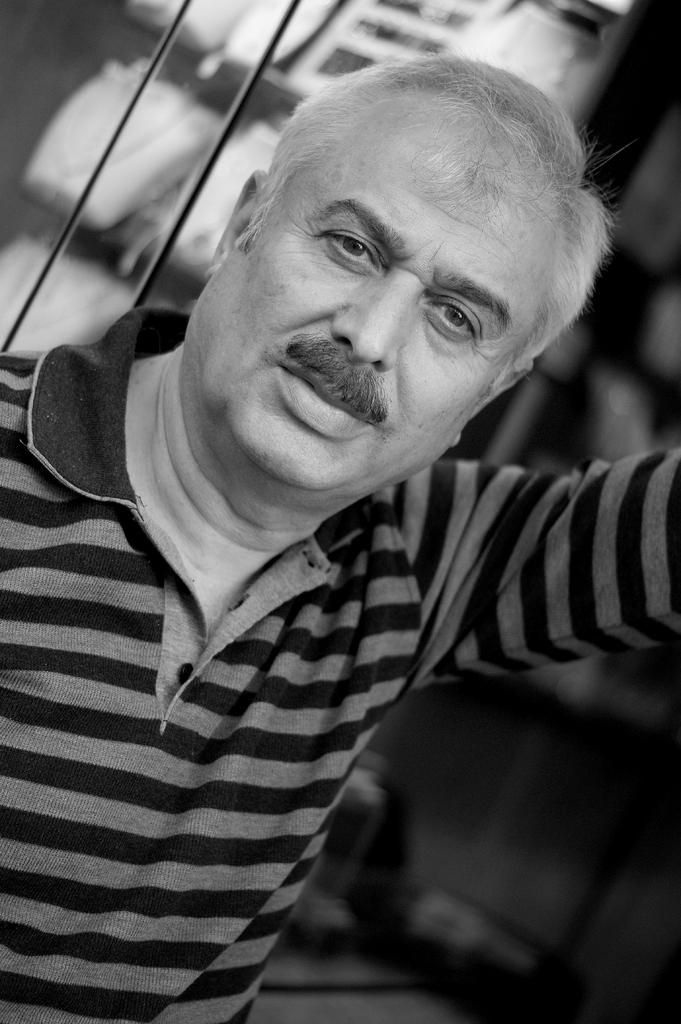What is the color scheme of the image? The image is black and white. Who or what is the main subject in the image? There is a man in the image. What can be seen behind the man in the image? The background contains glass and objects. How does the crowd affect the acoustics in the image? There is no crowd present in the image, so it is not possible to determine how they might affect the acoustics. 